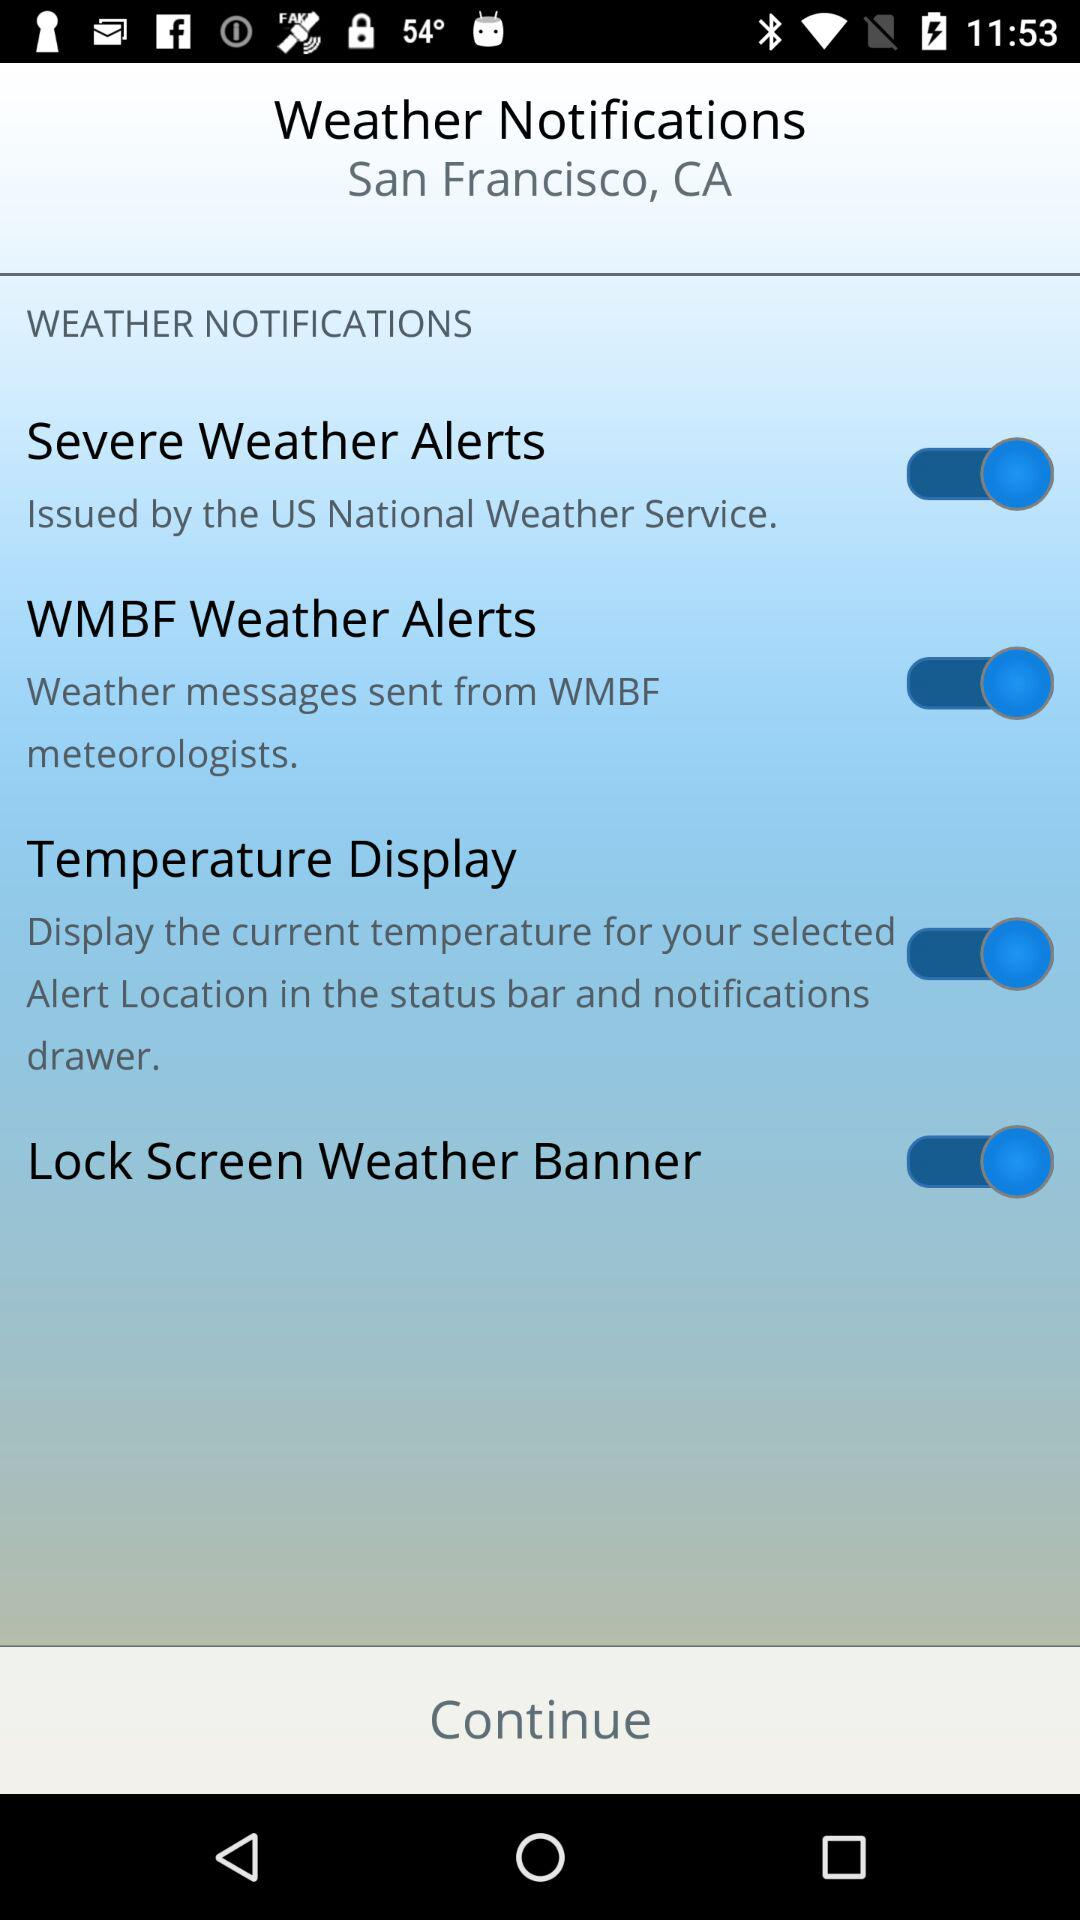By which agency were "Severe Weather Alerts" issued? "Severe Weather Alerts" were issued by the "US National Weather Service". 